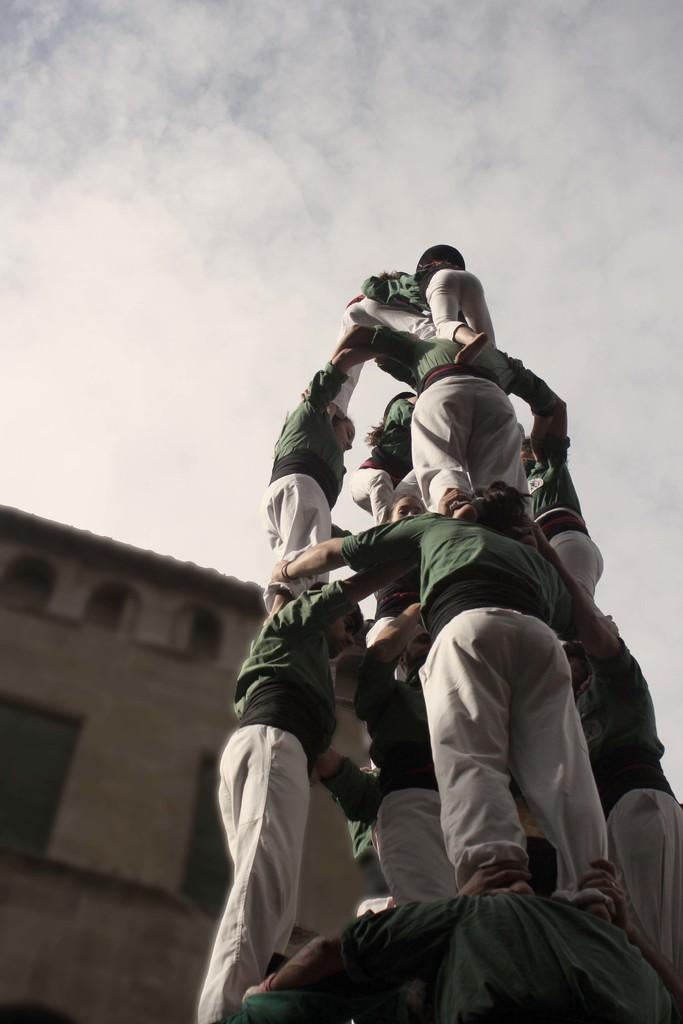In one or two sentences, can you explain what this image depicts? This picture shows few people standing one upon another and we see a building and a cloudy sky. 